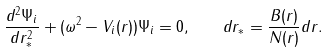Convert formula to latex. <formula><loc_0><loc_0><loc_500><loc_500>\frac { d ^ { 2 } \Psi _ { i } } { d r _ { * } ^ { 2 } } + ( \omega ^ { 2 } - V _ { i } ( r ) ) \Psi _ { i } = 0 , \quad d r _ { * } = \frac { B ( r ) } { N ( r ) } d r .</formula> 